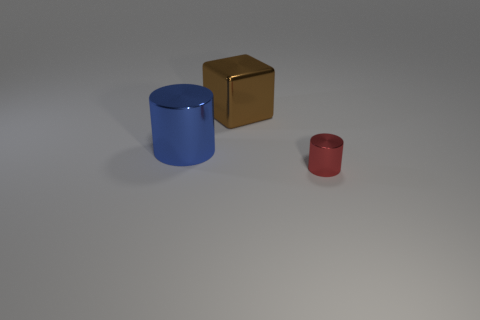Add 3 blue spheres. How many objects exist? 6 Subtract all cylinders. How many objects are left? 1 Subtract 0 purple blocks. How many objects are left? 3 Subtract all big brown things. Subtract all gray matte cylinders. How many objects are left? 2 Add 3 red things. How many red things are left? 4 Add 1 big cyan matte objects. How many big cyan matte objects exist? 1 